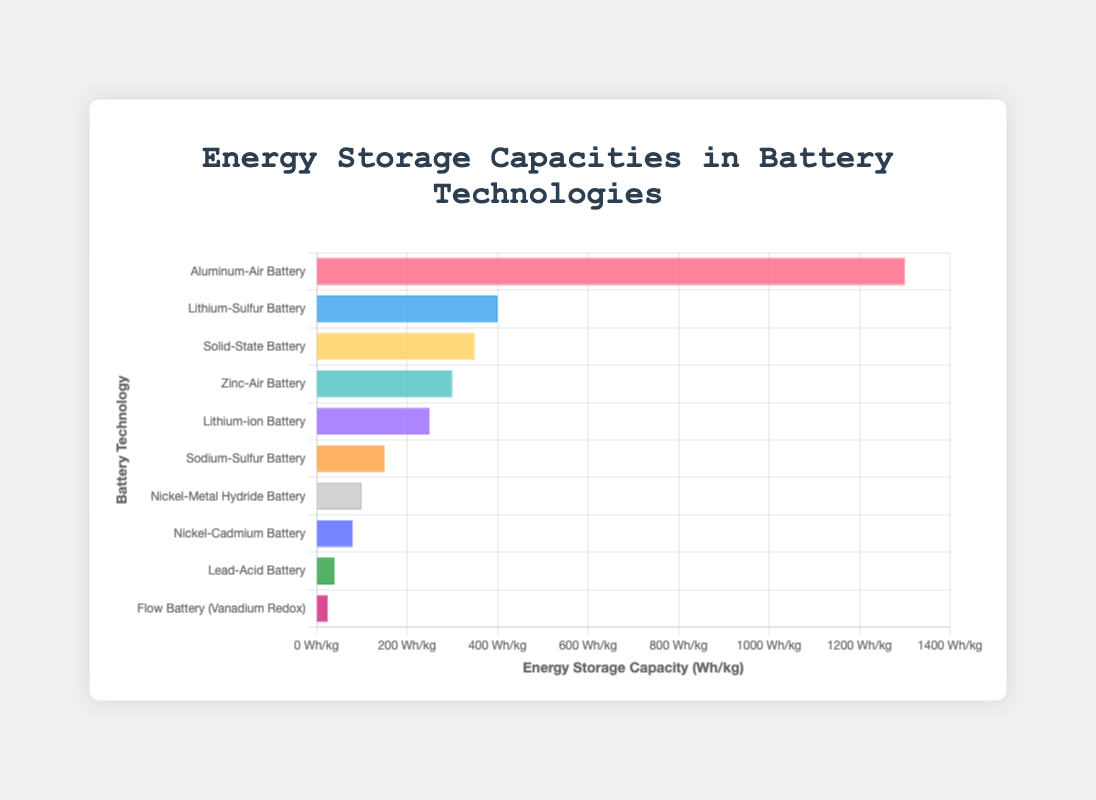Which battery technology has the highest energy storage capacity? The battery technology with the highest energy storage capacity can be seen by identifying the longest bar in the chart. The longest bar represents the Aluminum-Air Battery with 1300 Wh/kg.
Answer: Aluminum-Air Battery Which battery technology has the lowest energy storage capacity? The battery technology with the lowest energy storage capacity can be seen by identifying the shortest bar in the chart. The shortest bar represents the Flow Battery (Vanadium Redox) with 25 Wh/kg.
Answer: Flow Battery (Vanadium Redox) What is the difference in energy storage capacity between Lithium-Sulfur Battery and Lithium-ion Battery? To find the difference, subtract the energy storage capacity of the Lithium-ion Battery from that of the Lithium-Sulfur Battery: 400 Wh/kg - 250 Wh/kg = 150 Wh/kg.
Answer: 150 Wh/kg Which battery technologies have an energy storage capacity greater than 300 Wh/kg? Battery technologies with bars longer than the one representing 300 Wh/kg are Aluminum-Air Battery (1300 Wh/kg), Lithium-Sulfur Battery (400 Wh/kg), Solid-State Battery (350 Wh/kg), and Zinc-Air Battery (300 Wh/kg).
Answer: Aluminum-Air Battery, Lithium-Sulfur Battery, Solid-State Battery, Zinc-Air Battery Among the Nickel-Cadmium and Nickel-Metal Hydride batteries, which has a higher energy storage capacity and by how much? Comparing the bars of the Nickel-Cadmium Battery (80 Wh/kg) and the Nickel-Metal Hydride Battery (100 Wh/kg), the Nickel-Metal Hydride Battery has a higher capacity. The difference is 100 Wh/kg - 80 Wh/kg = 20 Wh/kg.
Answer: Nickel-Metal Hydride Battery, 20 Wh/kg What is the average energy storage capacity of Sodium-Sulfur Battery, Zinc-Air Battery, and Solid-State Battery? To find the average, add the capacities and then divide by the number of batteries: (150 Wh/kg + 300 Wh/kg + 350 Wh/kg) / 3 = 800 Wh/kg / 3 ≈ 266.67 Wh/kg.
Answer: 266.67 Wh/kg How many battery technologies have an energy storage capacity less than 100 Wh/kg? The battery technologies with bars representing less than 100 Wh/kg are Flow Battery (Vanadium Redox) (25 Wh/kg), Lead-Acid Battery (40 Wh/kg), and Nickel-Cadmium Battery (80 Wh/kg), which count to three.
Answer: 3 What do the colors of the bars generally represent? The chart uses different colors to represent distinct battery technologies, aiding in visual differentiation among categories. Each color corresponds to a different battery technology.
Answer: Different battery technologies Which battery technology has an energy storage capacity twice as much as Sodium-Sulfur Battery? To find the battery with twice the capacity of Sodium-Sulfur Battery (150 Wh/kg): 150 Wh/kg * 2 = 300 Wh/kg. The Zinc-Air Battery matches this with 300 Wh/kg.
Answer: Zinc-Air Battery 